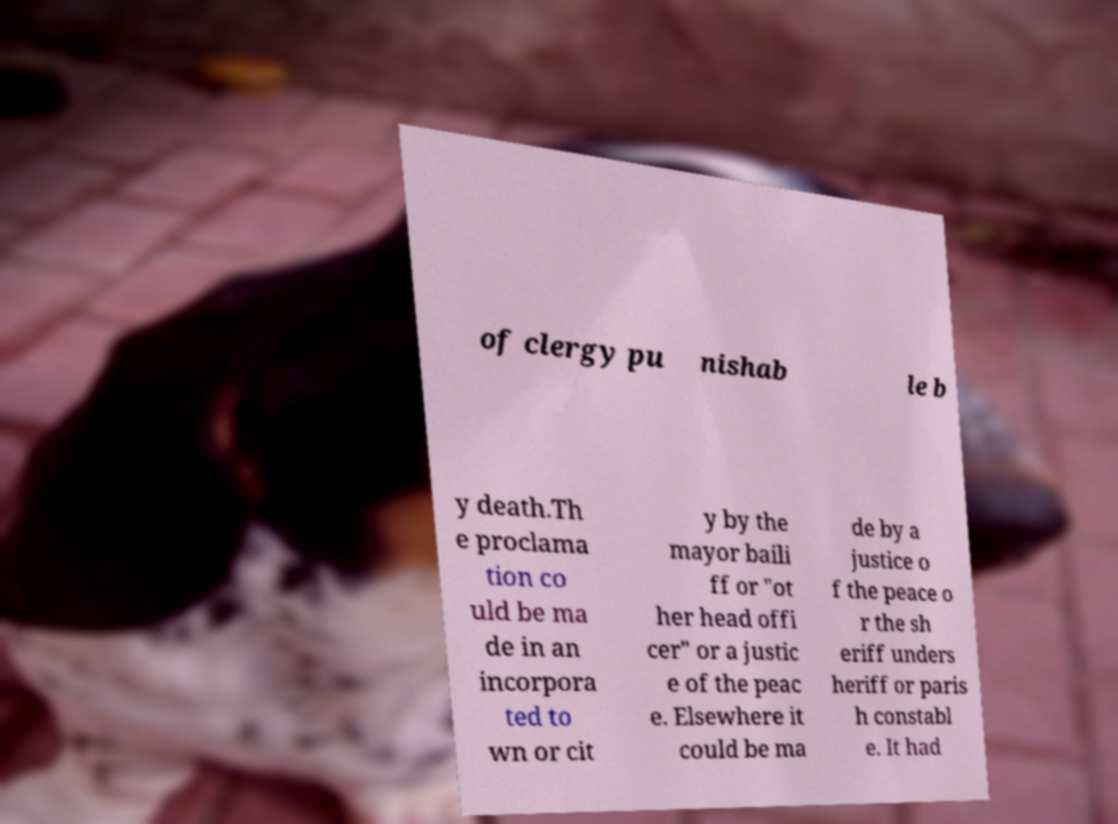Can you read and provide the text displayed in the image?This photo seems to have some interesting text. Can you extract and type it out for me? of clergy pu nishab le b y death.Th e proclama tion co uld be ma de in an incorpora ted to wn or cit y by the mayor baili ff or "ot her head offi cer" or a justic e of the peac e. Elsewhere it could be ma de by a justice o f the peace o r the sh eriff unders heriff or paris h constabl e. It had 